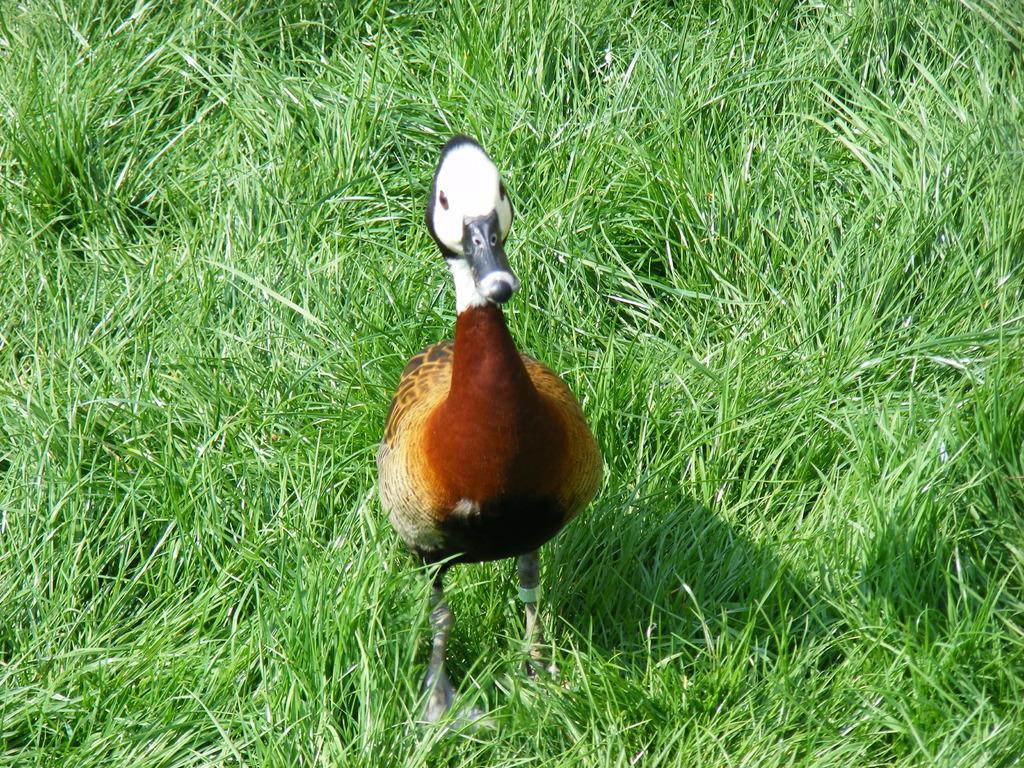How would you summarize this image in a sentence or two? In the image, we can see bird. Background we can see grass all over the image. 